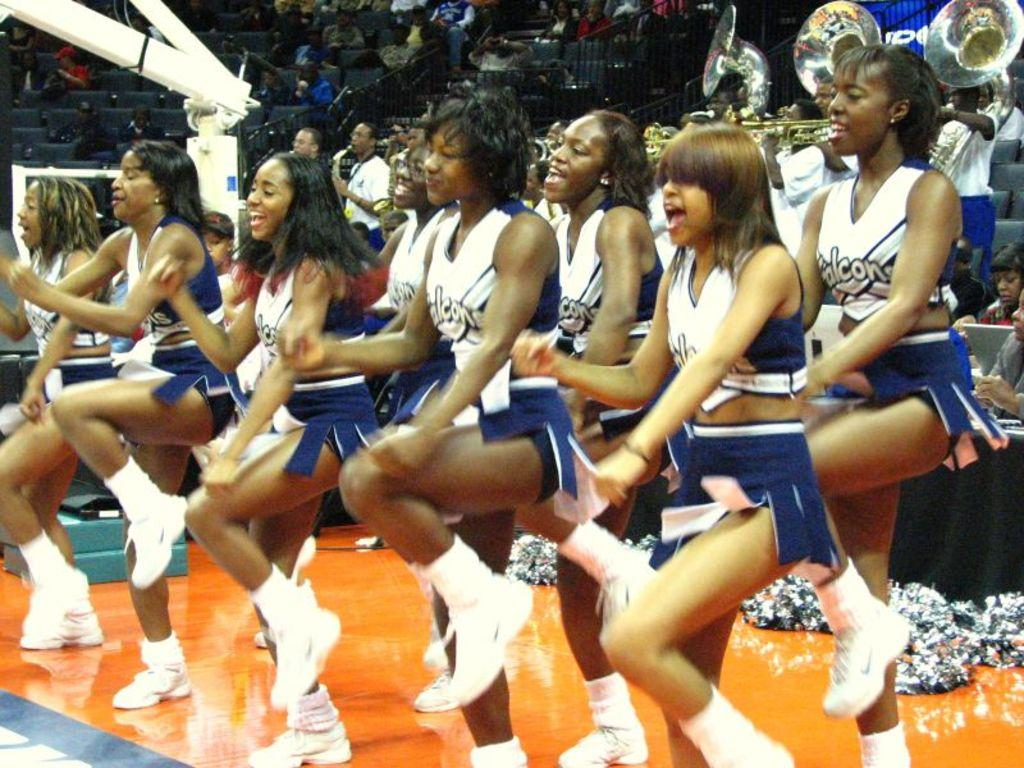<image>
Share a concise interpretation of the image provided. Falcons cheerleaders on the sidelines of a game near the band. 